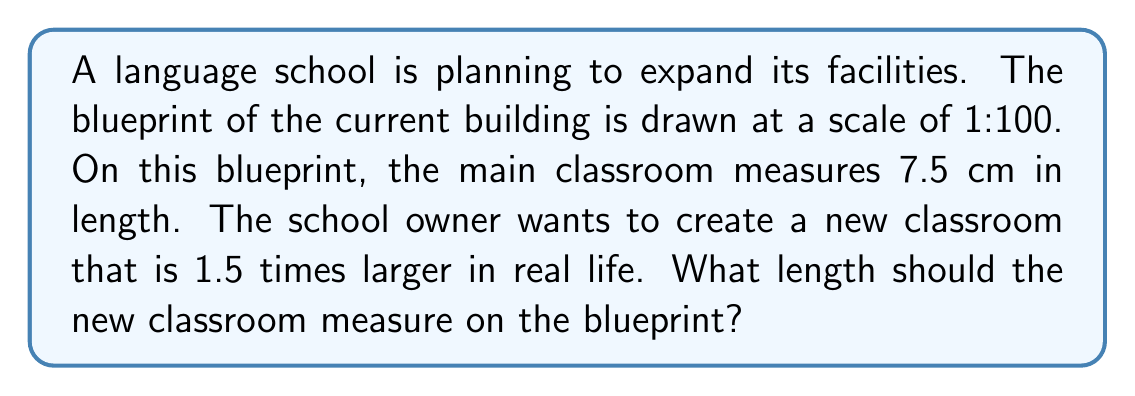What is the answer to this math problem? Let's approach this step-by-step:

1) First, we need to find the actual size of the current classroom:
   - Scale is 1:100, meaning 1 cm on the blueprint represents 100 cm in reality
   - The classroom measures 7.5 cm on the blueprint
   - Actual length = $7.5 \times 100 = 750$ cm = 7.5 m

2) Now, we calculate the size of the new classroom in reality:
   - The new classroom should be 1.5 times larger
   - New actual length = $7.5 \text{ m} \times 1.5 = 11.25$ m

3) Finally, we convert the new actual length back to the blueprint scale:
   - We need to divide the actual length by 100 to get the blueprint measurement
   - Blueprint length = $11.25 \text{ m} \div 100 = 0.1125$ m = 11.25 cm

Therefore, the new classroom should measure 11.25 cm on the blueprint.
Answer: 11.25 cm 